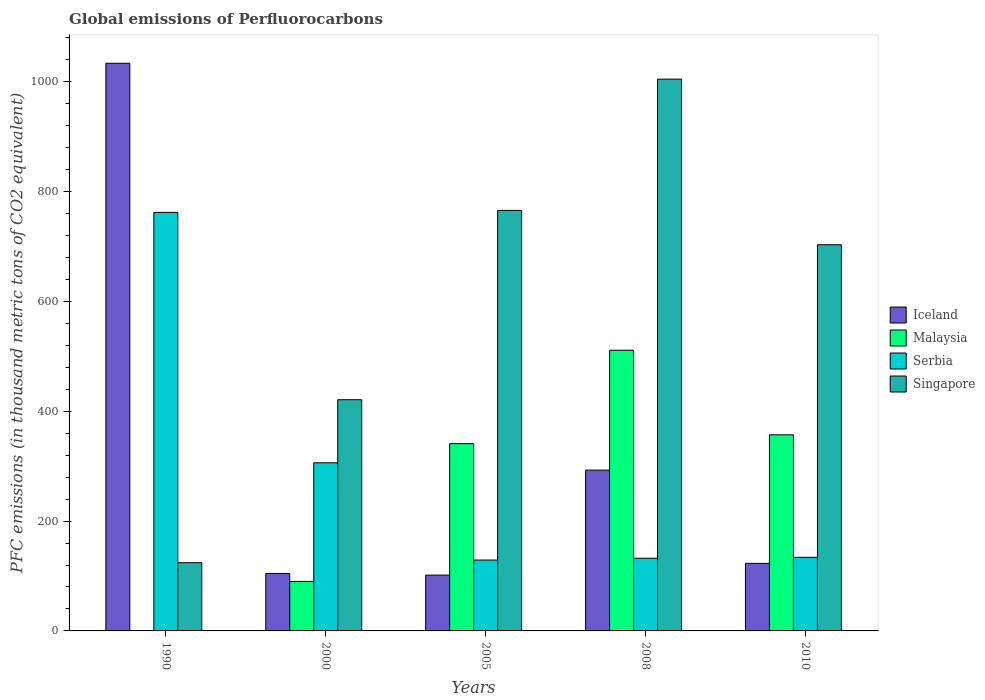Are the number of bars on each tick of the X-axis equal?
Your response must be concise. Yes. How many bars are there on the 4th tick from the right?
Make the answer very short. 4. What is the global emissions of Perfluorocarbons in Malaysia in 2005?
Give a very brief answer. 340.9. Across all years, what is the maximum global emissions of Perfluorocarbons in Iceland?
Provide a succinct answer. 1033.4. Across all years, what is the minimum global emissions of Perfluorocarbons in Iceland?
Ensure brevity in your answer.  101.6. What is the total global emissions of Perfluorocarbons in Iceland in the graph?
Make the answer very short. 1655.3. What is the difference between the global emissions of Perfluorocarbons in Malaysia in 2000 and that in 2008?
Your answer should be very brief. -420.9. What is the difference between the global emissions of Perfluorocarbons in Singapore in 2000 and the global emissions of Perfluorocarbons in Iceland in 2005?
Your answer should be very brief. 319.3. What is the average global emissions of Perfluorocarbons in Serbia per year?
Provide a succinct answer. 292.66. In the year 2010, what is the difference between the global emissions of Perfluorocarbons in Singapore and global emissions of Perfluorocarbons in Iceland?
Offer a terse response. 580. In how many years, is the global emissions of Perfluorocarbons in Malaysia greater than 320 thousand metric tons?
Ensure brevity in your answer.  3. What is the ratio of the global emissions of Perfluorocarbons in Iceland in 2000 to that in 2005?
Offer a terse response. 1.03. Is the difference between the global emissions of Perfluorocarbons in Singapore in 2005 and 2010 greater than the difference between the global emissions of Perfluorocarbons in Iceland in 2005 and 2010?
Your answer should be compact. Yes. What is the difference between the highest and the second highest global emissions of Perfluorocarbons in Malaysia?
Ensure brevity in your answer.  154. What is the difference between the highest and the lowest global emissions of Perfluorocarbons in Iceland?
Your answer should be very brief. 931.8. In how many years, is the global emissions of Perfluorocarbons in Iceland greater than the average global emissions of Perfluorocarbons in Iceland taken over all years?
Give a very brief answer. 1. What does the 2nd bar from the left in 1990 represents?
Offer a very short reply. Malaysia. What does the 2nd bar from the right in 1990 represents?
Provide a short and direct response. Serbia. Are all the bars in the graph horizontal?
Provide a succinct answer. No. Does the graph contain grids?
Make the answer very short. No. Where does the legend appear in the graph?
Your response must be concise. Center right. How many legend labels are there?
Your response must be concise. 4. What is the title of the graph?
Provide a short and direct response. Global emissions of Perfluorocarbons. What is the label or title of the X-axis?
Make the answer very short. Years. What is the label or title of the Y-axis?
Keep it short and to the point. PFC emissions (in thousand metric tons of CO2 equivalent). What is the PFC emissions (in thousand metric tons of CO2 equivalent) of Iceland in 1990?
Keep it short and to the point. 1033.4. What is the PFC emissions (in thousand metric tons of CO2 equivalent) of Malaysia in 1990?
Provide a succinct answer. 0.6. What is the PFC emissions (in thousand metric tons of CO2 equivalent) in Serbia in 1990?
Keep it short and to the point. 761.9. What is the PFC emissions (in thousand metric tons of CO2 equivalent) in Singapore in 1990?
Your answer should be very brief. 124.2. What is the PFC emissions (in thousand metric tons of CO2 equivalent) of Iceland in 2000?
Offer a very short reply. 104.6. What is the PFC emissions (in thousand metric tons of CO2 equivalent) of Malaysia in 2000?
Your answer should be very brief. 90.1. What is the PFC emissions (in thousand metric tons of CO2 equivalent) of Serbia in 2000?
Make the answer very short. 306.1. What is the PFC emissions (in thousand metric tons of CO2 equivalent) in Singapore in 2000?
Give a very brief answer. 420.9. What is the PFC emissions (in thousand metric tons of CO2 equivalent) in Iceland in 2005?
Your answer should be compact. 101.6. What is the PFC emissions (in thousand metric tons of CO2 equivalent) in Malaysia in 2005?
Offer a terse response. 340.9. What is the PFC emissions (in thousand metric tons of CO2 equivalent) of Serbia in 2005?
Provide a short and direct response. 129. What is the PFC emissions (in thousand metric tons of CO2 equivalent) in Singapore in 2005?
Provide a succinct answer. 765.5. What is the PFC emissions (in thousand metric tons of CO2 equivalent) of Iceland in 2008?
Offer a very short reply. 292.7. What is the PFC emissions (in thousand metric tons of CO2 equivalent) of Malaysia in 2008?
Provide a short and direct response. 511. What is the PFC emissions (in thousand metric tons of CO2 equivalent) in Serbia in 2008?
Your answer should be compact. 132.3. What is the PFC emissions (in thousand metric tons of CO2 equivalent) in Singapore in 2008?
Keep it short and to the point. 1004.5. What is the PFC emissions (in thousand metric tons of CO2 equivalent) of Iceland in 2010?
Give a very brief answer. 123. What is the PFC emissions (in thousand metric tons of CO2 equivalent) of Malaysia in 2010?
Keep it short and to the point. 357. What is the PFC emissions (in thousand metric tons of CO2 equivalent) in Serbia in 2010?
Make the answer very short. 134. What is the PFC emissions (in thousand metric tons of CO2 equivalent) of Singapore in 2010?
Offer a terse response. 703. Across all years, what is the maximum PFC emissions (in thousand metric tons of CO2 equivalent) in Iceland?
Ensure brevity in your answer.  1033.4. Across all years, what is the maximum PFC emissions (in thousand metric tons of CO2 equivalent) of Malaysia?
Your response must be concise. 511. Across all years, what is the maximum PFC emissions (in thousand metric tons of CO2 equivalent) in Serbia?
Offer a terse response. 761.9. Across all years, what is the maximum PFC emissions (in thousand metric tons of CO2 equivalent) of Singapore?
Your response must be concise. 1004.5. Across all years, what is the minimum PFC emissions (in thousand metric tons of CO2 equivalent) of Iceland?
Your answer should be very brief. 101.6. Across all years, what is the minimum PFC emissions (in thousand metric tons of CO2 equivalent) of Malaysia?
Offer a terse response. 0.6. Across all years, what is the minimum PFC emissions (in thousand metric tons of CO2 equivalent) in Serbia?
Keep it short and to the point. 129. Across all years, what is the minimum PFC emissions (in thousand metric tons of CO2 equivalent) in Singapore?
Keep it short and to the point. 124.2. What is the total PFC emissions (in thousand metric tons of CO2 equivalent) of Iceland in the graph?
Make the answer very short. 1655.3. What is the total PFC emissions (in thousand metric tons of CO2 equivalent) in Malaysia in the graph?
Keep it short and to the point. 1299.6. What is the total PFC emissions (in thousand metric tons of CO2 equivalent) in Serbia in the graph?
Provide a short and direct response. 1463.3. What is the total PFC emissions (in thousand metric tons of CO2 equivalent) of Singapore in the graph?
Offer a very short reply. 3018.1. What is the difference between the PFC emissions (in thousand metric tons of CO2 equivalent) of Iceland in 1990 and that in 2000?
Provide a succinct answer. 928.8. What is the difference between the PFC emissions (in thousand metric tons of CO2 equivalent) of Malaysia in 1990 and that in 2000?
Provide a short and direct response. -89.5. What is the difference between the PFC emissions (in thousand metric tons of CO2 equivalent) of Serbia in 1990 and that in 2000?
Give a very brief answer. 455.8. What is the difference between the PFC emissions (in thousand metric tons of CO2 equivalent) of Singapore in 1990 and that in 2000?
Give a very brief answer. -296.7. What is the difference between the PFC emissions (in thousand metric tons of CO2 equivalent) of Iceland in 1990 and that in 2005?
Ensure brevity in your answer.  931.8. What is the difference between the PFC emissions (in thousand metric tons of CO2 equivalent) in Malaysia in 1990 and that in 2005?
Make the answer very short. -340.3. What is the difference between the PFC emissions (in thousand metric tons of CO2 equivalent) in Serbia in 1990 and that in 2005?
Offer a terse response. 632.9. What is the difference between the PFC emissions (in thousand metric tons of CO2 equivalent) in Singapore in 1990 and that in 2005?
Offer a terse response. -641.3. What is the difference between the PFC emissions (in thousand metric tons of CO2 equivalent) of Iceland in 1990 and that in 2008?
Your answer should be compact. 740.7. What is the difference between the PFC emissions (in thousand metric tons of CO2 equivalent) of Malaysia in 1990 and that in 2008?
Provide a short and direct response. -510.4. What is the difference between the PFC emissions (in thousand metric tons of CO2 equivalent) of Serbia in 1990 and that in 2008?
Ensure brevity in your answer.  629.6. What is the difference between the PFC emissions (in thousand metric tons of CO2 equivalent) in Singapore in 1990 and that in 2008?
Offer a very short reply. -880.3. What is the difference between the PFC emissions (in thousand metric tons of CO2 equivalent) of Iceland in 1990 and that in 2010?
Provide a succinct answer. 910.4. What is the difference between the PFC emissions (in thousand metric tons of CO2 equivalent) of Malaysia in 1990 and that in 2010?
Give a very brief answer. -356.4. What is the difference between the PFC emissions (in thousand metric tons of CO2 equivalent) in Serbia in 1990 and that in 2010?
Offer a very short reply. 627.9. What is the difference between the PFC emissions (in thousand metric tons of CO2 equivalent) of Singapore in 1990 and that in 2010?
Offer a very short reply. -578.8. What is the difference between the PFC emissions (in thousand metric tons of CO2 equivalent) of Malaysia in 2000 and that in 2005?
Offer a terse response. -250.8. What is the difference between the PFC emissions (in thousand metric tons of CO2 equivalent) of Serbia in 2000 and that in 2005?
Offer a terse response. 177.1. What is the difference between the PFC emissions (in thousand metric tons of CO2 equivalent) in Singapore in 2000 and that in 2005?
Give a very brief answer. -344.6. What is the difference between the PFC emissions (in thousand metric tons of CO2 equivalent) of Iceland in 2000 and that in 2008?
Give a very brief answer. -188.1. What is the difference between the PFC emissions (in thousand metric tons of CO2 equivalent) in Malaysia in 2000 and that in 2008?
Keep it short and to the point. -420.9. What is the difference between the PFC emissions (in thousand metric tons of CO2 equivalent) of Serbia in 2000 and that in 2008?
Provide a succinct answer. 173.8. What is the difference between the PFC emissions (in thousand metric tons of CO2 equivalent) of Singapore in 2000 and that in 2008?
Offer a terse response. -583.6. What is the difference between the PFC emissions (in thousand metric tons of CO2 equivalent) of Iceland in 2000 and that in 2010?
Keep it short and to the point. -18.4. What is the difference between the PFC emissions (in thousand metric tons of CO2 equivalent) in Malaysia in 2000 and that in 2010?
Offer a terse response. -266.9. What is the difference between the PFC emissions (in thousand metric tons of CO2 equivalent) of Serbia in 2000 and that in 2010?
Your response must be concise. 172.1. What is the difference between the PFC emissions (in thousand metric tons of CO2 equivalent) in Singapore in 2000 and that in 2010?
Ensure brevity in your answer.  -282.1. What is the difference between the PFC emissions (in thousand metric tons of CO2 equivalent) of Iceland in 2005 and that in 2008?
Your answer should be compact. -191.1. What is the difference between the PFC emissions (in thousand metric tons of CO2 equivalent) in Malaysia in 2005 and that in 2008?
Your response must be concise. -170.1. What is the difference between the PFC emissions (in thousand metric tons of CO2 equivalent) of Serbia in 2005 and that in 2008?
Provide a short and direct response. -3.3. What is the difference between the PFC emissions (in thousand metric tons of CO2 equivalent) of Singapore in 2005 and that in 2008?
Keep it short and to the point. -239. What is the difference between the PFC emissions (in thousand metric tons of CO2 equivalent) of Iceland in 2005 and that in 2010?
Your answer should be compact. -21.4. What is the difference between the PFC emissions (in thousand metric tons of CO2 equivalent) in Malaysia in 2005 and that in 2010?
Give a very brief answer. -16.1. What is the difference between the PFC emissions (in thousand metric tons of CO2 equivalent) in Serbia in 2005 and that in 2010?
Give a very brief answer. -5. What is the difference between the PFC emissions (in thousand metric tons of CO2 equivalent) in Singapore in 2005 and that in 2010?
Provide a short and direct response. 62.5. What is the difference between the PFC emissions (in thousand metric tons of CO2 equivalent) in Iceland in 2008 and that in 2010?
Your answer should be very brief. 169.7. What is the difference between the PFC emissions (in thousand metric tons of CO2 equivalent) of Malaysia in 2008 and that in 2010?
Keep it short and to the point. 154. What is the difference between the PFC emissions (in thousand metric tons of CO2 equivalent) of Singapore in 2008 and that in 2010?
Ensure brevity in your answer.  301.5. What is the difference between the PFC emissions (in thousand metric tons of CO2 equivalent) of Iceland in 1990 and the PFC emissions (in thousand metric tons of CO2 equivalent) of Malaysia in 2000?
Offer a terse response. 943.3. What is the difference between the PFC emissions (in thousand metric tons of CO2 equivalent) of Iceland in 1990 and the PFC emissions (in thousand metric tons of CO2 equivalent) of Serbia in 2000?
Your answer should be compact. 727.3. What is the difference between the PFC emissions (in thousand metric tons of CO2 equivalent) in Iceland in 1990 and the PFC emissions (in thousand metric tons of CO2 equivalent) in Singapore in 2000?
Provide a succinct answer. 612.5. What is the difference between the PFC emissions (in thousand metric tons of CO2 equivalent) of Malaysia in 1990 and the PFC emissions (in thousand metric tons of CO2 equivalent) of Serbia in 2000?
Offer a terse response. -305.5. What is the difference between the PFC emissions (in thousand metric tons of CO2 equivalent) in Malaysia in 1990 and the PFC emissions (in thousand metric tons of CO2 equivalent) in Singapore in 2000?
Your answer should be compact. -420.3. What is the difference between the PFC emissions (in thousand metric tons of CO2 equivalent) in Serbia in 1990 and the PFC emissions (in thousand metric tons of CO2 equivalent) in Singapore in 2000?
Your response must be concise. 341. What is the difference between the PFC emissions (in thousand metric tons of CO2 equivalent) of Iceland in 1990 and the PFC emissions (in thousand metric tons of CO2 equivalent) of Malaysia in 2005?
Give a very brief answer. 692.5. What is the difference between the PFC emissions (in thousand metric tons of CO2 equivalent) of Iceland in 1990 and the PFC emissions (in thousand metric tons of CO2 equivalent) of Serbia in 2005?
Offer a terse response. 904.4. What is the difference between the PFC emissions (in thousand metric tons of CO2 equivalent) in Iceland in 1990 and the PFC emissions (in thousand metric tons of CO2 equivalent) in Singapore in 2005?
Ensure brevity in your answer.  267.9. What is the difference between the PFC emissions (in thousand metric tons of CO2 equivalent) in Malaysia in 1990 and the PFC emissions (in thousand metric tons of CO2 equivalent) in Serbia in 2005?
Make the answer very short. -128.4. What is the difference between the PFC emissions (in thousand metric tons of CO2 equivalent) in Malaysia in 1990 and the PFC emissions (in thousand metric tons of CO2 equivalent) in Singapore in 2005?
Provide a succinct answer. -764.9. What is the difference between the PFC emissions (in thousand metric tons of CO2 equivalent) of Iceland in 1990 and the PFC emissions (in thousand metric tons of CO2 equivalent) of Malaysia in 2008?
Ensure brevity in your answer.  522.4. What is the difference between the PFC emissions (in thousand metric tons of CO2 equivalent) of Iceland in 1990 and the PFC emissions (in thousand metric tons of CO2 equivalent) of Serbia in 2008?
Your answer should be compact. 901.1. What is the difference between the PFC emissions (in thousand metric tons of CO2 equivalent) of Iceland in 1990 and the PFC emissions (in thousand metric tons of CO2 equivalent) of Singapore in 2008?
Ensure brevity in your answer.  28.9. What is the difference between the PFC emissions (in thousand metric tons of CO2 equivalent) in Malaysia in 1990 and the PFC emissions (in thousand metric tons of CO2 equivalent) in Serbia in 2008?
Your answer should be compact. -131.7. What is the difference between the PFC emissions (in thousand metric tons of CO2 equivalent) of Malaysia in 1990 and the PFC emissions (in thousand metric tons of CO2 equivalent) of Singapore in 2008?
Offer a very short reply. -1003.9. What is the difference between the PFC emissions (in thousand metric tons of CO2 equivalent) of Serbia in 1990 and the PFC emissions (in thousand metric tons of CO2 equivalent) of Singapore in 2008?
Provide a succinct answer. -242.6. What is the difference between the PFC emissions (in thousand metric tons of CO2 equivalent) of Iceland in 1990 and the PFC emissions (in thousand metric tons of CO2 equivalent) of Malaysia in 2010?
Your response must be concise. 676.4. What is the difference between the PFC emissions (in thousand metric tons of CO2 equivalent) in Iceland in 1990 and the PFC emissions (in thousand metric tons of CO2 equivalent) in Serbia in 2010?
Your answer should be compact. 899.4. What is the difference between the PFC emissions (in thousand metric tons of CO2 equivalent) of Iceland in 1990 and the PFC emissions (in thousand metric tons of CO2 equivalent) of Singapore in 2010?
Offer a very short reply. 330.4. What is the difference between the PFC emissions (in thousand metric tons of CO2 equivalent) in Malaysia in 1990 and the PFC emissions (in thousand metric tons of CO2 equivalent) in Serbia in 2010?
Make the answer very short. -133.4. What is the difference between the PFC emissions (in thousand metric tons of CO2 equivalent) of Malaysia in 1990 and the PFC emissions (in thousand metric tons of CO2 equivalent) of Singapore in 2010?
Keep it short and to the point. -702.4. What is the difference between the PFC emissions (in thousand metric tons of CO2 equivalent) of Serbia in 1990 and the PFC emissions (in thousand metric tons of CO2 equivalent) of Singapore in 2010?
Your answer should be compact. 58.9. What is the difference between the PFC emissions (in thousand metric tons of CO2 equivalent) of Iceland in 2000 and the PFC emissions (in thousand metric tons of CO2 equivalent) of Malaysia in 2005?
Provide a succinct answer. -236.3. What is the difference between the PFC emissions (in thousand metric tons of CO2 equivalent) in Iceland in 2000 and the PFC emissions (in thousand metric tons of CO2 equivalent) in Serbia in 2005?
Keep it short and to the point. -24.4. What is the difference between the PFC emissions (in thousand metric tons of CO2 equivalent) of Iceland in 2000 and the PFC emissions (in thousand metric tons of CO2 equivalent) of Singapore in 2005?
Give a very brief answer. -660.9. What is the difference between the PFC emissions (in thousand metric tons of CO2 equivalent) in Malaysia in 2000 and the PFC emissions (in thousand metric tons of CO2 equivalent) in Serbia in 2005?
Give a very brief answer. -38.9. What is the difference between the PFC emissions (in thousand metric tons of CO2 equivalent) in Malaysia in 2000 and the PFC emissions (in thousand metric tons of CO2 equivalent) in Singapore in 2005?
Offer a very short reply. -675.4. What is the difference between the PFC emissions (in thousand metric tons of CO2 equivalent) in Serbia in 2000 and the PFC emissions (in thousand metric tons of CO2 equivalent) in Singapore in 2005?
Provide a short and direct response. -459.4. What is the difference between the PFC emissions (in thousand metric tons of CO2 equivalent) in Iceland in 2000 and the PFC emissions (in thousand metric tons of CO2 equivalent) in Malaysia in 2008?
Your answer should be very brief. -406.4. What is the difference between the PFC emissions (in thousand metric tons of CO2 equivalent) of Iceland in 2000 and the PFC emissions (in thousand metric tons of CO2 equivalent) of Serbia in 2008?
Your response must be concise. -27.7. What is the difference between the PFC emissions (in thousand metric tons of CO2 equivalent) in Iceland in 2000 and the PFC emissions (in thousand metric tons of CO2 equivalent) in Singapore in 2008?
Offer a very short reply. -899.9. What is the difference between the PFC emissions (in thousand metric tons of CO2 equivalent) in Malaysia in 2000 and the PFC emissions (in thousand metric tons of CO2 equivalent) in Serbia in 2008?
Offer a terse response. -42.2. What is the difference between the PFC emissions (in thousand metric tons of CO2 equivalent) of Malaysia in 2000 and the PFC emissions (in thousand metric tons of CO2 equivalent) of Singapore in 2008?
Your answer should be very brief. -914.4. What is the difference between the PFC emissions (in thousand metric tons of CO2 equivalent) of Serbia in 2000 and the PFC emissions (in thousand metric tons of CO2 equivalent) of Singapore in 2008?
Offer a terse response. -698.4. What is the difference between the PFC emissions (in thousand metric tons of CO2 equivalent) in Iceland in 2000 and the PFC emissions (in thousand metric tons of CO2 equivalent) in Malaysia in 2010?
Give a very brief answer. -252.4. What is the difference between the PFC emissions (in thousand metric tons of CO2 equivalent) of Iceland in 2000 and the PFC emissions (in thousand metric tons of CO2 equivalent) of Serbia in 2010?
Your answer should be compact. -29.4. What is the difference between the PFC emissions (in thousand metric tons of CO2 equivalent) in Iceland in 2000 and the PFC emissions (in thousand metric tons of CO2 equivalent) in Singapore in 2010?
Provide a succinct answer. -598.4. What is the difference between the PFC emissions (in thousand metric tons of CO2 equivalent) of Malaysia in 2000 and the PFC emissions (in thousand metric tons of CO2 equivalent) of Serbia in 2010?
Give a very brief answer. -43.9. What is the difference between the PFC emissions (in thousand metric tons of CO2 equivalent) in Malaysia in 2000 and the PFC emissions (in thousand metric tons of CO2 equivalent) in Singapore in 2010?
Your answer should be very brief. -612.9. What is the difference between the PFC emissions (in thousand metric tons of CO2 equivalent) of Serbia in 2000 and the PFC emissions (in thousand metric tons of CO2 equivalent) of Singapore in 2010?
Offer a very short reply. -396.9. What is the difference between the PFC emissions (in thousand metric tons of CO2 equivalent) of Iceland in 2005 and the PFC emissions (in thousand metric tons of CO2 equivalent) of Malaysia in 2008?
Ensure brevity in your answer.  -409.4. What is the difference between the PFC emissions (in thousand metric tons of CO2 equivalent) in Iceland in 2005 and the PFC emissions (in thousand metric tons of CO2 equivalent) in Serbia in 2008?
Provide a short and direct response. -30.7. What is the difference between the PFC emissions (in thousand metric tons of CO2 equivalent) in Iceland in 2005 and the PFC emissions (in thousand metric tons of CO2 equivalent) in Singapore in 2008?
Your response must be concise. -902.9. What is the difference between the PFC emissions (in thousand metric tons of CO2 equivalent) of Malaysia in 2005 and the PFC emissions (in thousand metric tons of CO2 equivalent) of Serbia in 2008?
Provide a succinct answer. 208.6. What is the difference between the PFC emissions (in thousand metric tons of CO2 equivalent) in Malaysia in 2005 and the PFC emissions (in thousand metric tons of CO2 equivalent) in Singapore in 2008?
Your answer should be very brief. -663.6. What is the difference between the PFC emissions (in thousand metric tons of CO2 equivalent) in Serbia in 2005 and the PFC emissions (in thousand metric tons of CO2 equivalent) in Singapore in 2008?
Your answer should be very brief. -875.5. What is the difference between the PFC emissions (in thousand metric tons of CO2 equivalent) of Iceland in 2005 and the PFC emissions (in thousand metric tons of CO2 equivalent) of Malaysia in 2010?
Your answer should be compact. -255.4. What is the difference between the PFC emissions (in thousand metric tons of CO2 equivalent) of Iceland in 2005 and the PFC emissions (in thousand metric tons of CO2 equivalent) of Serbia in 2010?
Keep it short and to the point. -32.4. What is the difference between the PFC emissions (in thousand metric tons of CO2 equivalent) of Iceland in 2005 and the PFC emissions (in thousand metric tons of CO2 equivalent) of Singapore in 2010?
Make the answer very short. -601.4. What is the difference between the PFC emissions (in thousand metric tons of CO2 equivalent) of Malaysia in 2005 and the PFC emissions (in thousand metric tons of CO2 equivalent) of Serbia in 2010?
Offer a terse response. 206.9. What is the difference between the PFC emissions (in thousand metric tons of CO2 equivalent) in Malaysia in 2005 and the PFC emissions (in thousand metric tons of CO2 equivalent) in Singapore in 2010?
Provide a succinct answer. -362.1. What is the difference between the PFC emissions (in thousand metric tons of CO2 equivalent) in Serbia in 2005 and the PFC emissions (in thousand metric tons of CO2 equivalent) in Singapore in 2010?
Provide a succinct answer. -574. What is the difference between the PFC emissions (in thousand metric tons of CO2 equivalent) of Iceland in 2008 and the PFC emissions (in thousand metric tons of CO2 equivalent) of Malaysia in 2010?
Make the answer very short. -64.3. What is the difference between the PFC emissions (in thousand metric tons of CO2 equivalent) of Iceland in 2008 and the PFC emissions (in thousand metric tons of CO2 equivalent) of Serbia in 2010?
Offer a terse response. 158.7. What is the difference between the PFC emissions (in thousand metric tons of CO2 equivalent) of Iceland in 2008 and the PFC emissions (in thousand metric tons of CO2 equivalent) of Singapore in 2010?
Offer a very short reply. -410.3. What is the difference between the PFC emissions (in thousand metric tons of CO2 equivalent) of Malaysia in 2008 and the PFC emissions (in thousand metric tons of CO2 equivalent) of Serbia in 2010?
Your answer should be very brief. 377. What is the difference between the PFC emissions (in thousand metric tons of CO2 equivalent) in Malaysia in 2008 and the PFC emissions (in thousand metric tons of CO2 equivalent) in Singapore in 2010?
Give a very brief answer. -192. What is the difference between the PFC emissions (in thousand metric tons of CO2 equivalent) in Serbia in 2008 and the PFC emissions (in thousand metric tons of CO2 equivalent) in Singapore in 2010?
Your answer should be very brief. -570.7. What is the average PFC emissions (in thousand metric tons of CO2 equivalent) in Iceland per year?
Offer a very short reply. 331.06. What is the average PFC emissions (in thousand metric tons of CO2 equivalent) in Malaysia per year?
Ensure brevity in your answer.  259.92. What is the average PFC emissions (in thousand metric tons of CO2 equivalent) in Serbia per year?
Offer a very short reply. 292.66. What is the average PFC emissions (in thousand metric tons of CO2 equivalent) in Singapore per year?
Offer a very short reply. 603.62. In the year 1990, what is the difference between the PFC emissions (in thousand metric tons of CO2 equivalent) in Iceland and PFC emissions (in thousand metric tons of CO2 equivalent) in Malaysia?
Offer a terse response. 1032.8. In the year 1990, what is the difference between the PFC emissions (in thousand metric tons of CO2 equivalent) in Iceland and PFC emissions (in thousand metric tons of CO2 equivalent) in Serbia?
Ensure brevity in your answer.  271.5. In the year 1990, what is the difference between the PFC emissions (in thousand metric tons of CO2 equivalent) of Iceland and PFC emissions (in thousand metric tons of CO2 equivalent) of Singapore?
Your response must be concise. 909.2. In the year 1990, what is the difference between the PFC emissions (in thousand metric tons of CO2 equivalent) in Malaysia and PFC emissions (in thousand metric tons of CO2 equivalent) in Serbia?
Provide a succinct answer. -761.3. In the year 1990, what is the difference between the PFC emissions (in thousand metric tons of CO2 equivalent) in Malaysia and PFC emissions (in thousand metric tons of CO2 equivalent) in Singapore?
Your answer should be very brief. -123.6. In the year 1990, what is the difference between the PFC emissions (in thousand metric tons of CO2 equivalent) of Serbia and PFC emissions (in thousand metric tons of CO2 equivalent) of Singapore?
Ensure brevity in your answer.  637.7. In the year 2000, what is the difference between the PFC emissions (in thousand metric tons of CO2 equivalent) of Iceland and PFC emissions (in thousand metric tons of CO2 equivalent) of Malaysia?
Offer a very short reply. 14.5. In the year 2000, what is the difference between the PFC emissions (in thousand metric tons of CO2 equivalent) of Iceland and PFC emissions (in thousand metric tons of CO2 equivalent) of Serbia?
Offer a terse response. -201.5. In the year 2000, what is the difference between the PFC emissions (in thousand metric tons of CO2 equivalent) of Iceland and PFC emissions (in thousand metric tons of CO2 equivalent) of Singapore?
Ensure brevity in your answer.  -316.3. In the year 2000, what is the difference between the PFC emissions (in thousand metric tons of CO2 equivalent) of Malaysia and PFC emissions (in thousand metric tons of CO2 equivalent) of Serbia?
Keep it short and to the point. -216. In the year 2000, what is the difference between the PFC emissions (in thousand metric tons of CO2 equivalent) of Malaysia and PFC emissions (in thousand metric tons of CO2 equivalent) of Singapore?
Provide a short and direct response. -330.8. In the year 2000, what is the difference between the PFC emissions (in thousand metric tons of CO2 equivalent) of Serbia and PFC emissions (in thousand metric tons of CO2 equivalent) of Singapore?
Ensure brevity in your answer.  -114.8. In the year 2005, what is the difference between the PFC emissions (in thousand metric tons of CO2 equivalent) in Iceland and PFC emissions (in thousand metric tons of CO2 equivalent) in Malaysia?
Keep it short and to the point. -239.3. In the year 2005, what is the difference between the PFC emissions (in thousand metric tons of CO2 equivalent) in Iceland and PFC emissions (in thousand metric tons of CO2 equivalent) in Serbia?
Your answer should be very brief. -27.4. In the year 2005, what is the difference between the PFC emissions (in thousand metric tons of CO2 equivalent) of Iceland and PFC emissions (in thousand metric tons of CO2 equivalent) of Singapore?
Make the answer very short. -663.9. In the year 2005, what is the difference between the PFC emissions (in thousand metric tons of CO2 equivalent) in Malaysia and PFC emissions (in thousand metric tons of CO2 equivalent) in Serbia?
Offer a terse response. 211.9. In the year 2005, what is the difference between the PFC emissions (in thousand metric tons of CO2 equivalent) of Malaysia and PFC emissions (in thousand metric tons of CO2 equivalent) of Singapore?
Keep it short and to the point. -424.6. In the year 2005, what is the difference between the PFC emissions (in thousand metric tons of CO2 equivalent) of Serbia and PFC emissions (in thousand metric tons of CO2 equivalent) of Singapore?
Ensure brevity in your answer.  -636.5. In the year 2008, what is the difference between the PFC emissions (in thousand metric tons of CO2 equivalent) of Iceland and PFC emissions (in thousand metric tons of CO2 equivalent) of Malaysia?
Offer a very short reply. -218.3. In the year 2008, what is the difference between the PFC emissions (in thousand metric tons of CO2 equivalent) in Iceland and PFC emissions (in thousand metric tons of CO2 equivalent) in Serbia?
Ensure brevity in your answer.  160.4. In the year 2008, what is the difference between the PFC emissions (in thousand metric tons of CO2 equivalent) of Iceland and PFC emissions (in thousand metric tons of CO2 equivalent) of Singapore?
Provide a succinct answer. -711.8. In the year 2008, what is the difference between the PFC emissions (in thousand metric tons of CO2 equivalent) in Malaysia and PFC emissions (in thousand metric tons of CO2 equivalent) in Serbia?
Offer a very short reply. 378.7. In the year 2008, what is the difference between the PFC emissions (in thousand metric tons of CO2 equivalent) in Malaysia and PFC emissions (in thousand metric tons of CO2 equivalent) in Singapore?
Your answer should be compact. -493.5. In the year 2008, what is the difference between the PFC emissions (in thousand metric tons of CO2 equivalent) in Serbia and PFC emissions (in thousand metric tons of CO2 equivalent) in Singapore?
Provide a succinct answer. -872.2. In the year 2010, what is the difference between the PFC emissions (in thousand metric tons of CO2 equivalent) in Iceland and PFC emissions (in thousand metric tons of CO2 equivalent) in Malaysia?
Make the answer very short. -234. In the year 2010, what is the difference between the PFC emissions (in thousand metric tons of CO2 equivalent) in Iceland and PFC emissions (in thousand metric tons of CO2 equivalent) in Singapore?
Offer a terse response. -580. In the year 2010, what is the difference between the PFC emissions (in thousand metric tons of CO2 equivalent) in Malaysia and PFC emissions (in thousand metric tons of CO2 equivalent) in Serbia?
Your response must be concise. 223. In the year 2010, what is the difference between the PFC emissions (in thousand metric tons of CO2 equivalent) in Malaysia and PFC emissions (in thousand metric tons of CO2 equivalent) in Singapore?
Your answer should be very brief. -346. In the year 2010, what is the difference between the PFC emissions (in thousand metric tons of CO2 equivalent) of Serbia and PFC emissions (in thousand metric tons of CO2 equivalent) of Singapore?
Give a very brief answer. -569. What is the ratio of the PFC emissions (in thousand metric tons of CO2 equivalent) in Iceland in 1990 to that in 2000?
Give a very brief answer. 9.88. What is the ratio of the PFC emissions (in thousand metric tons of CO2 equivalent) in Malaysia in 1990 to that in 2000?
Make the answer very short. 0.01. What is the ratio of the PFC emissions (in thousand metric tons of CO2 equivalent) in Serbia in 1990 to that in 2000?
Your answer should be compact. 2.49. What is the ratio of the PFC emissions (in thousand metric tons of CO2 equivalent) in Singapore in 1990 to that in 2000?
Ensure brevity in your answer.  0.3. What is the ratio of the PFC emissions (in thousand metric tons of CO2 equivalent) of Iceland in 1990 to that in 2005?
Your response must be concise. 10.17. What is the ratio of the PFC emissions (in thousand metric tons of CO2 equivalent) of Malaysia in 1990 to that in 2005?
Provide a succinct answer. 0. What is the ratio of the PFC emissions (in thousand metric tons of CO2 equivalent) in Serbia in 1990 to that in 2005?
Give a very brief answer. 5.91. What is the ratio of the PFC emissions (in thousand metric tons of CO2 equivalent) of Singapore in 1990 to that in 2005?
Make the answer very short. 0.16. What is the ratio of the PFC emissions (in thousand metric tons of CO2 equivalent) in Iceland in 1990 to that in 2008?
Your answer should be very brief. 3.53. What is the ratio of the PFC emissions (in thousand metric tons of CO2 equivalent) in Malaysia in 1990 to that in 2008?
Keep it short and to the point. 0. What is the ratio of the PFC emissions (in thousand metric tons of CO2 equivalent) in Serbia in 1990 to that in 2008?
Offer a very short reply. 5.76. What is the ratio of the PFC emissions (in thousand metric tons of CO2 equivalent) in Singapore in 1990 to that in 2008?
Your answer should be very brief. 0.12. What is the ratio of the PFC emissions (in thousand metric tons of CO2 equivalent) of Iceland in 1990 to that in 2010?
Provide a short and direct response. 8.4. What is the ratio of the PFC emissions (in thousand metric tons of CO2 equivalent) in Malaysia in 1990 to that in 2010?
Your answer should be compact. 0. What is the ratio of the PFC emissions (in thousand metric tons of CO2 equivalent) in Serbia in 1990 to that in 2010?
Provide a short and direct response. 5.69. What is the ratio of the PFC emissions (in thousand metric tons of CO2 equivalent) of Singapore in 1990 to that in 2010?
Your answer should be compact. 0.18. What is the ratio of the PFC emissions (in thousand metric tons of CO2 equivalent) of Iceland in 2000 to that in 2005?
Your answer should be compact. 1.03. What is the ratio of the PFC emissions (in thousand metric tons of CO2 equivalent) of Malaysia in 2000 to that in 2005?
Offer a very short reply. 0.26. What is the ratio of the PFC emissions (in thousand metric tons of CO2 equivalent) in Serbia in 2000 to that in 2005?
Offer a very short reply. 2.37. What is the ratio of the PFC emissions (in thousand metric tons of CO2 equivalent) of Singapore in 2000 to that in 2005?
Your response must be concise. 0.55. What is the ratio of the PFC emissions (in thousand metric tons of CO2 equivalent) of Iceland in 2000 to that in 2008?
Keep it short and to the point. 0.36. What is the ratio of the PFC emissions (in thousand metric tons of CO2 equivalent) of Malaysia in 2000 to that in 2008?
Your answer should be very brief. 0.18. What is the ratio of the PFC emissions (in thousand metric tons of CO2 equivalent) in Serbia in 2000 to that in 2008?
Make the answer very short. 2.31. What is the ratio of the PFC emissions (in thousand metric tons of CO2 equivalent) in Singapore in 2000 to that in 2008?
Keep it short and to the point. 0.42. What is the ratio of the PFC emissions (in thousand metric tons of CO2 equivalent) of Iceland in 2000 to that in 2010?
Provide a succinct answer. 0.85. What is the ratio of the PFC emissions (in thousand metric tons of CO2 equivalent) of Malaysia in 2000 to that in 2010?
Keep it short and to the point. 0.25. What is the ratio of the PFC emissions (in thousand metric tons of CO2 equivalent) in Serbia in 2000 to that in 2010?
Make the answer very short. 2.28. What is the ratio of the PFC emissions (in thousand metric tons of CO2 equivalent) in Singapore in 2000 to that in 2010?
Give a very brief answer. 0.6. What is the ratio of the PFC emissions (in thousand metric tons of CO2 equivalent) in Iceland in 2005 to that in 2008?
Ensure brevity in your answer.  0.35. What is the ratio of the PFC emissions (in thousand metric tons of CO2 equivalent) in Malaysia in 2005 to that in 2008?
Your response must be concise. 0.67. What is the ratio of the PFC emissions (in thousand metric tons of CO2 equivalent) of Serbia in 2005 to that in 2008?
Your answer should be very brief. 0.98. What is the ratio of the PFC emissions (in thousand metric tons of CO2 equivalent) in Singapore in 2005 to that in 2008?
Provide a short and direct response. 0.76. What is the ratio of the PFC emissions (in thousand metric tons of CO2 equivalent) of Iceland in 2005 to that in 2010?
Ensure brevity in your answer.  0.83. What is the ratio of the PFC emissions (in thousand metric tons of CO2 equivalent) in Malaysia in 2005 to that in 2010?
Keep it short and to the point. 0.95. What is the ratio of the PFC emissions (in thousand metric tons of CO2 equivalent) in Serbia in 2005 to that in 2010?
Make the answer very short. 0.96. What is the ratio of the PFC emissions (in thousand metric tons of CO2 equivalent) in Singapore in 2005 to that in 2010?
Keep it short and to the point. 1.09. What is the ratio of the PFC emissions (in thousand metric tons of CO2 equivalent) in Iceland in 2008 to that in 2010?
Keep it short and to the point. 2.38. What is the ratio of the PFC emissions (in thousand metric tons of CO2 equivalent) of Malaysia in 2008 to that in 2010?
Keep it short and to the point. 1.43. What is the ratio of the PFC emissions (in thousand metric tons of CO2 equivalent) of Serbia in 2008 to that in 2010?
Offer a very short reply. 0.99. What is the ratio of the PFC emissions (in thousand metric tons of CO2 equivalent) of Singapore in 2008 to that in 2010?
Your answer should be very brief. 1.43. What is the difference between the highest and the second highest PFC emissions (in thousand metric tons of CO2 equivalent) of Iceland?
Your answer should be compact. 740.7. What is the difference between the highest and the second highest PFC emissions (in thousand metric tons of CO2 equivalent) in Malaysia?
Ensure brevity in your answer.  154. What is the difference between the highest and the second highest PFC emissions (in thousand metric tons of CO2 equivalent) of Serbia?
Offer a very short reply. 455.8. What is the difference between the highest and the second highest PFC emissions (in thousand metric tons of CO2 equivalent) of Singapore?
Your answer should be compact. 239. What is the difference between the highest and the lowest PFC emissions (in thousand metric tons of CO2 equivalent) in Iceland?
Ensure brevity in your answer.  931.8. What is the difference between the highest and the lowest PFC emissions (in thousand metric tons of CO2 equivalent) in Malaysia?
Keep it short and to the point. 510.4. What is the difference between the highest and the lowest PFC emissions (in thousand metric tons of CO2 equivalent) in Serbia?
Provide a succinct answer. 632.9. What is the difference between the highest and the lowest PFC emissions (in thousand metric tons of CO2 equivalent) in Singapore?
Your answer should be compact. 880.3. 